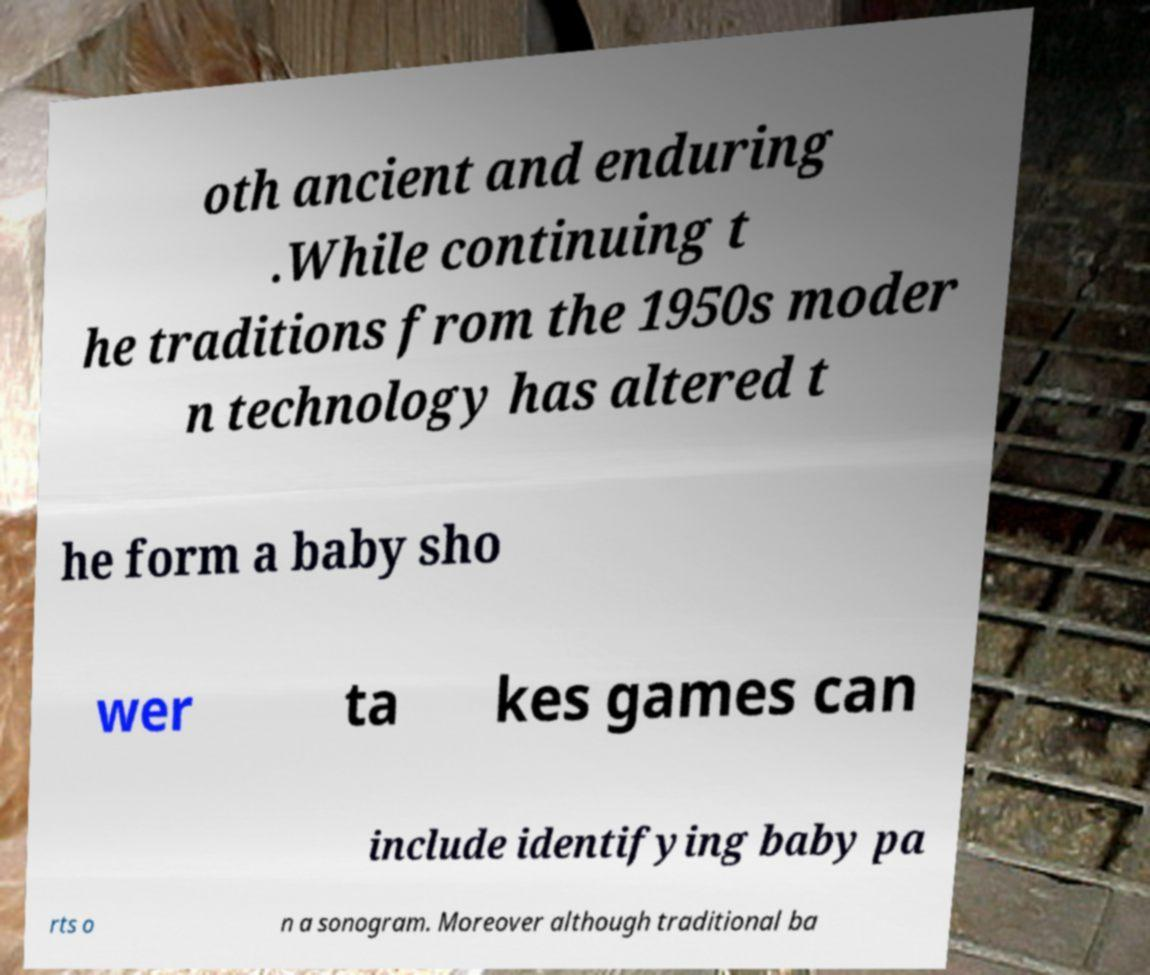I need the written content from this picture converted into text. Can you do that? oth ancient and enduring .While continuing t he traditions from the 1950s moder n technology has altered t he form a baby sho wer ta kes games can include identifying baby pa rts o n a sonogram. Moreover although traditional ba 